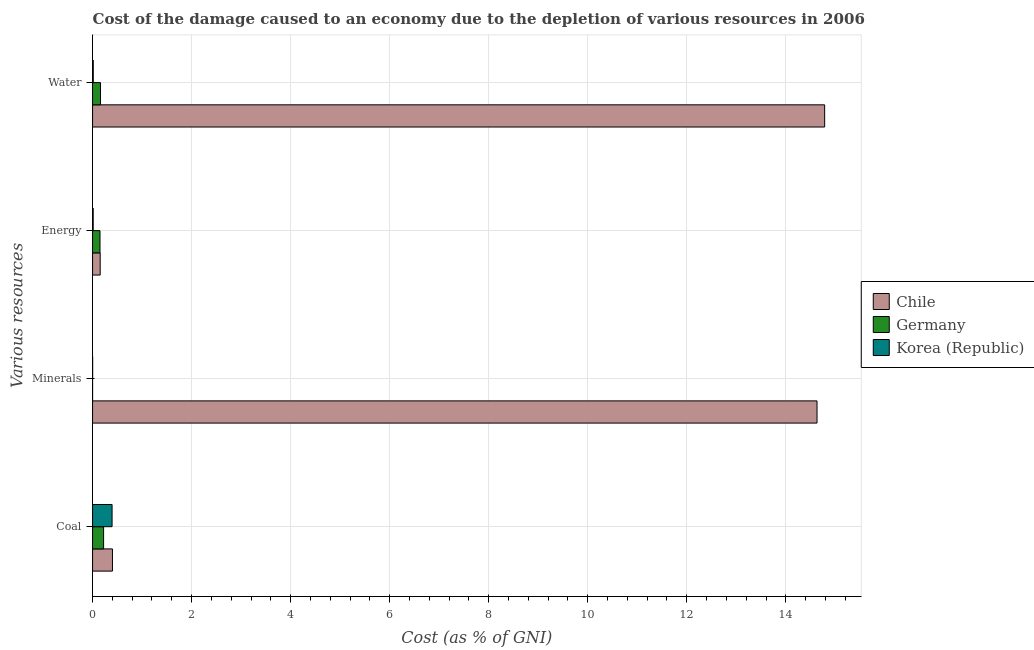How many groups of bars are there?
Provide a short and direct response. 4. How many bars are there on the 1st tick from the top?
Your answer should be compact. 3. How many bars are there on the 1st tick from the bottom?
Ensure brevity in your answer.  3. What is the label of the 3rd group of bars from the top?
Provide a short and direct response. Minerals. What is the cost of damage due to depletion of water in Korea (Republic)?
Offer a terse response. 0.01. Across all countries, what is the maximum cost of damage due to depletion of energy?
Provide a succinct answer. 0.15. Across all countries, what is the minimum cost of damage due to depletion of minerals?
Ensure brevity in your answer.  0. What is the total cost of damage due to depletion of minerals in the graph?
Provide a short and direct response. 14.63. What is the difference between the cost of damage due to depletion of energy in Korea (Republic) and that in Chile?
Offer a terse response. -0.14. What is the difference between the cost of damage due to depletion of water in Korea (Republic) and the cost of damage due to depletion of energy in Chile?
Keep it short and to the point. -0.14. What is the average cost of damage due to depletion of coal per country?
Offer a terse response. 0.34. What is the difference between the cost of damage due to depletion of energy and cost of damage due to depletion of coal in Germany?
Offer a very short reply. -0.07. What is the ratio of the cost of damage due to depletion of water in Korea (Republic) to that in Germany?
Your response must be concise. 0.09. Is the difference between the cost of damage due to depletion of coal in Korea (Republic) and Germany greater than the difference between the cost of damage due to depletion of water in Korea (Republic) and Germany?
Keep it short and to the point. Yes. What is the difference between the highest and the second highest cost of damage due to depletion of water?
Provide a succinct answer. 14.62. What is the difference between the highest and the lowest cost of damage due to depletion of coal?
Make the answer very short. 0.18. In how many countries, is the cost of damage due to depletion of coal greater than the average cost of damage due to depletion of coal taken over all countries?
Ensure brevity in your answer.  2. What does the 3rd bar from the bottom in Water represents?
Provide a succinct answer. Korea (Republic). Is it the case that in every country, the sum of the cost of damage due to depletion of coal and cost of damage due to depletion of minerals is greater than the cost of damage due to depletion of energy?
Offer a very short reply. Yes. Are all the bars in the graph horizontal?
Give a very brief answer. Yes. How many countries are there in the graph?
Offer a terse response. 3. What is the difference between two consecutive major ticks on the X-axis?
Keep it short and to the point. 2. Are the values on the major ticks of X-axis written in scientific E-notation?
Ensure brevity in your answer.  No. Does the graph contain grids?
Give a very brief answer. Yes. How many legend labels are there?
Your answer should be compact. 3. How are the legend labels stacked?
Give a very brief answer. Vertical. What is the title of the graph?
Your answer should be very brief. Cost of the damage caused to an economy due to the depletion of various resources in 2006 . What is the label or title of the X-axis?
Your response must be concise. Cost (as % of GNI). What is the label or title of the Y-axis?
Keep it short and to the point. Various resources. What is the Cost (as % of GNI) of Chile in Coal?
Offer a terse response. 0.4. What is the Cost (as % of GNI) of Germany in Coal?
Ensure brevity in your answer.  0.22. What is the Cost (as % of GNI) of Korea (Republic) in Coal?
Offer a terse response. 0.39. What is the Cost (as % of GNI) of Chile in Minerals?
Your response must be concise. 14.63. What is the Cost (as % of GNI) of Germany in Minerals?
Keep it short and to the point. 0. What is the Cost (as % of GNI) in Korea (Republic) in Minerals?
Make the answer very short. 0. What is the Cost (as % of GNI) in Chile in Energy?
Your response must be concise. 0.15. What is the Cost (as % of GNI) in Germany in Energy?
Keep it short and to the point. 0.15. What is the Cost (as % of GNI) in Korea (Republic) in Energy?
Your response must be concise. 0.01. What is the Cost (as % of GNI) in Chile in Water?
Offer a very short reply. 14.78. What is the Cost (as % of GNI) of Germany in Water?
Give a very brief answer. 0.16. What is the Cost (as % of GNI) of Korea (Republic) in Water?
Offer a very short reply. 0.01. Across all Various resources, what is the maximum Cost (as % of GNI) of Chile?
Offer a very short reply. 14.78. Across all Various resources, what is the maximum Cost (as % of GNI) in Germany?
Provide a short and direct response. 0.22. Across all Various resources, what is the maximum Cost (as % of GNI) in Korea (Republic)?
Provide a short and direct response. 0.39. Across all Various resources, what is the minimum Cost (as % of GNI) of Chile?
Your answer should be compact. 0.15. Across all Various resources, what is the minimum Cost (as % of GNI) in Germany?
Provide a short and direct response. 0. Across all Various resources, what is the minimum Cost (as % of GNI) of Korea (Republic)?
Ensure brevity in your answer.  0. What is the total Cost (as % of GNI) in Chile in the graph?
Ensure brevity in your answer.  29.97. What is the total Cost (as % of GNI) in Germany in the graph?
Provide a succinct answer. 0.53. What is the total Cost (as % of GNI) of Korea (Republic) in the graph?
Your response must be concise. 0.42. What is the difference between the Cost (as % of GNI) in Chile in Coal and that in Minerals?
Make the answer very short. -14.23. What is the difference between the Cost (as % of GNI) of Germany in Coal and that in Minerals?
Ensure brevity in your answer.  0.22. What is the difference between the Cost (as % of GNI) of Korea (Republic) in Coal and that in Minerals?
Keep it short and to the point. 0.39. What is the difference between the Cost (as % of GNI) in Chile in Coal and that in Energy?
Make the answer very short. 0.25. What is the difference between the Cost (as % of GNI) of Germany in Coal and that in Energy?
Offer a terse response. 0.07. What is the difference between the Cost (as % of GNI) of Korea (Republic) in Coal and that in Energy?
Keep it short and to the point. 0.38. What is the difference between the Cost (as % of GNI) of Chile in Coal and that in Water?
Offer a terse response. -14.38. What is the difference between the Cost (as % of GNI) of Germany in Coal and that in Water?
Provide a succinct answer. 0.06. What is the difference between the Cost (as % of GNI) in Korea (Republic) in Coal and that in Water?
Give a very brief answer. 0.38. What is the difference between the Cost (as % of GNI) in Chile in Minerals and that in Energy?
Make the answer very short. 14.48. What is the difference between the Cost (as % of GNI) in Korea (Republic) in Minerals and that in Energy?
Your answer should be very brief. -0.01. What is the difference between the Cost (as % of GNI) in Chile in Minerals and that in Water?
Your answer should be compact. -0.15. What is the difference between the Cost (as % of GNI) of Germany in Minerals and that in Water?
Ensure brevity in your answer.  -0.16. What is the difference between the Cost (as % of GNI) of Korea (Republic) in Minerals and that in Water?
Offer a terse response. -0.01. What is the difference between the Cost (as % of GNI) in Chile in Energy and that in Water?
Make the answer very short. -14.63. What is the difference between the Cost (as % of GNI) of Germany in Energy and that in Water?
Your answer should be very brief. -0.01. What is the difference between the Cost (as % of GNI) of Korea (Republic) in Energy and that in Water?
Keep it short and to the point. -0. What is the difference between the Cost (as % of GNI) in Chile in Coal and the Cost (as % of GNI) in Germany in Minerals?
Provide a short and direct response. 0.4. What is the difference between the Cost (as % of GNI) of Chile in Coal and the Cost (as % of GNI) of Korea (Republic) in Minerals?
Your answer should be compact. 0.4. What is the difference between the Cost (as % of GNI) in Germany in Coal and the Cost (as % of GNI) in Korea (Republic) in Minerals?
Keep it short and to the point. 0.22. What is the difference between the Cost (as % of GNI) in Chile in Coal and the Cost (as % of GNI) in Germany in Energy?
Keep it short and to the point. 0.25. What is the difference between the Cost (as % of GNI) in Chile in Coal and the Cost (as % of GNI) in Korea (Republic) in Energy?
Your response must be concise. 0.39. What is the difference between the Cost (as % of GNI) of Germany in Coal and the Cost (as % of GNI) of Korea (Republic) in Energy?
Offer a terse response. 0.21. What is the difference between the Cost (as % of GNI) of Chile in Coal and the Cost (as % of GNI) of Germany in Water?
Keep it short and to the point. 0.24. What is the difference between the Cost (as % of GNI) in Chile in Coal and the Cost (as % of GNI) in Korea (Republic) in Water?
Your answer should be very brief. 0.39. What is the difference between the Cost (as % of GNI) of Germany in Coal and the Cost (as % of GNI) of Korea (Republic) in Water?
Keep it short and to the point. 0.21. What is the difference between the Cost (as % of GNI) of Chile in Minerals and the Cost (as % of GNI) of Germany in Energy?
Provide a short and direct response. 14.48. What is the difference between the Cost (as % of GNI) of Chile in Minerals and the Cost (as % of GNI) of Korea (Republic) in Energy?
Ensure brevity in your answer.  14.62. What is the difference between the Cost (as % of GNI) of Germany in Minerals and the Cost (as % of GNI) of Korea (Republic) in Energy?
Offer a terse response. -0.01. What is the difference between the Cost (as % of GNI) of Chile in Minerals and the Cost (as % of GNI) of Germany in Water?
Provide a short and direct response. 14.47. What is the difference between the Cost (as % of GNI) in Chile in Minerals and the Cost (as % of GNI) in Korea (Republic) in Water?
Keep it short and to the point. 14.62. What is the difference between the Cost (as % of GNI) in Germany in Minerals and the Cost (as % of GNI) in Korea (Republic) in Water?
Give a very brief answer. -0.01. What is the difference between the Cost (as % of GNI) in Chile in Energy and the Cost (as % of GNI) in Germany in Water?
Your response must be concise. -0.01. What is the difference between the Cost (as % of GNI) in Chile in Energy and the Cost (as % of GNI) in Korea (Republic) in Water?
Make the answer very short. 0.14. What is the difference between the Cost (as % of GNI) in Germany in Energy and the Cost (as % of GNI) in Korea (Republic) in Water?
Offer a terse response. 0.14. What is the average Cost (as % of GNI) of Chile per Various resources?
Your answer should be compact. 7.49. What is the average Cost (as % of GNI) of Germany per Various resources?
Make the answer very short. 0.13. What is the average Cost (as % of GNI) of Korea (Republic) per Various resources?
Offer a very short reply. 0.11. What is the difference between the Cost (as % of GNI) of Chile and Cost (as % of GNI) of Germany in Coal?
Your answer should be compact. 0.18. What is the difference between the Cost (as % of GNI) of Chile and Cost (as % of GNI) of Korea (Republic) in Coal?
Your answer should be compact. 0.01. What is the difference between the Cost (as % of GNI) in Germany and Cost (as % of GNI) in Korea (Republic) in Coal?
Your response must be concise. -0.17. What is the difference between the Cost (as % of GNI) of Chile and Cost (as % of GNI) of Germany in Minerals?
Offer a very short reply. 14.63. What is the difference between the Cost (as % of GNI) of Chile and Cost (as % of GNI) of Korea (Republic) in Minerals?
Keep it short and to the point. 14.63. What is the difference between the Cost (as % of GNI) of Germany and Cost (as % of GNI) of Korea (Republic) in Minerals?
Keep it short and to the point. -0. What is the difference between the Cost (as % of GNI) in Chile and Cost (as % of GNI) in Germany in Energy?
Offer a terse response. 0. What is the difference between the Cost (as % of GNI) in Chile and Cost (as % of GNI) in Korea (Republic) in Energy?
Provide a short and direct response. 0.14. What is the difference between the Cost (as % of GNI) in Germany and Cost (as % of GNI) in Korea (Republic) in Energy?
Keep it short and to the point. 0.14. What is the difference between the Cost (as % of GNI) in Chile and Cost (as % of GNI) in Germany in Water?
Your response must be concise. 14.62. What is the difference between the Cost (as % of GNI) of Chile and Cost (as % of GNI) of Korea (Republic) in Water?
Provide a short and direct response. 14.77. What is the difference between the Cost (as % of GNI) of Germany and Cost (as % of GNI) of Korea (Republic) in Water?
Give a very brief answer. 0.15. What is the ratio of the Cost (as % of GNI) in Chile in Coal to that in Minerals?
Offer a very short reply. 0.03. What is the ratio of the Cost (as % of GNI) of Germany in Coal to that in Minerals?
Ensure brevity in your answer.  1221.32. What is the ratio of the Cost (as % of GNI) in Korea (Republic) in Coal to that in Minerals?
Provide a succinct answer. 292.47. What is the ratio of the Cost (as % of GNI) in Chile in Coal to that in Energy?
Provide a short and direct response. 2.61. What is the ratio of the Cost (as % of GNI) of Germany in Coal to that in Energy?
Keep it short and to the point. 1.48. What is the ratio of the Cost (as % of GNI) of Korea (Republic) in Coal to that in Energy?
Give a very brief answer. 31.21. What is the ratio of the Cost (as % of GNI) of Chile in Coal to that in Water?
Your answer should be compact. 0.03. What is the ratio of the Cost (as % of GNI) of Germany in Coal to that in Water?
Ensure brevity in your answer.  1.39. What is the ratio of the Cost (as % of GNI) in Korea (Republic) in Coal to that in Water?
Provide a succinct answer. 28.2. What is the ratio of the Cost (as % of GNI) in Chile in Minerals to that in Energy?
Offer a very short reply. 95. What is the ratio of the Cost (as % of GNI) in Germany in Minerals to that in Energy?
Give a very brief answer. 0. What is the ratio of the Cost (as % of GNI) in Korea (Republic) in Minerals to that in Energy?
Provide a short and direct response. 0.11. What is the ratio of the Cost (as % of GNI) in Chile in Minerals to that in Water?
Your response must be concise. 0.99. What is the ratio of the Cost (as % of GNI) in Germany in Minerals to that in Water?
Your answer should be very brief. 0. What is the ratio of the Cost (as % of GNI) in Korea (Republic) in Minerals to that in Water?
Keep it short and to the point. 0.1. What is the ratio of the Cost (as % of GNI) of Chile in Energy to that in Water?
Your response must be concise. 0.01. What is the ratio of the Cost (as % of GNI) of Germany in Energy to that in Water?
Provide a short and direct response. 0.94. What is the ratio of the Cost (as % of GNI) in Korea (Republic) in Energy to that in Water?
Your answer should be compact. 0.9. What is the difference between the highest and the second highest Cost (as % of GNI) of Chile?
Keep it short and to the point. 0.15. What is the difference between the highest and the second highest Cost (as % of GNI) in Germany?
Offer a terse response. 0.06. What is the difference between the highest and the second highest Cost (as % of GNI) of Korea (Republic)?
Keep it short and to the point. 0.38. What is the difference between the highest and the lowest Cost (as % of GNI) in Chile?
Make the answer very short. 14.63. What is the difference between the highest and the lowest Cost (as % of GNI) of Germany?
Provide a short and direct response. 0.22. What is the difference between the highest and the lowest Cost (as % of GNI) of Korea (Republic)?
Make the answer very short. 0.39. 